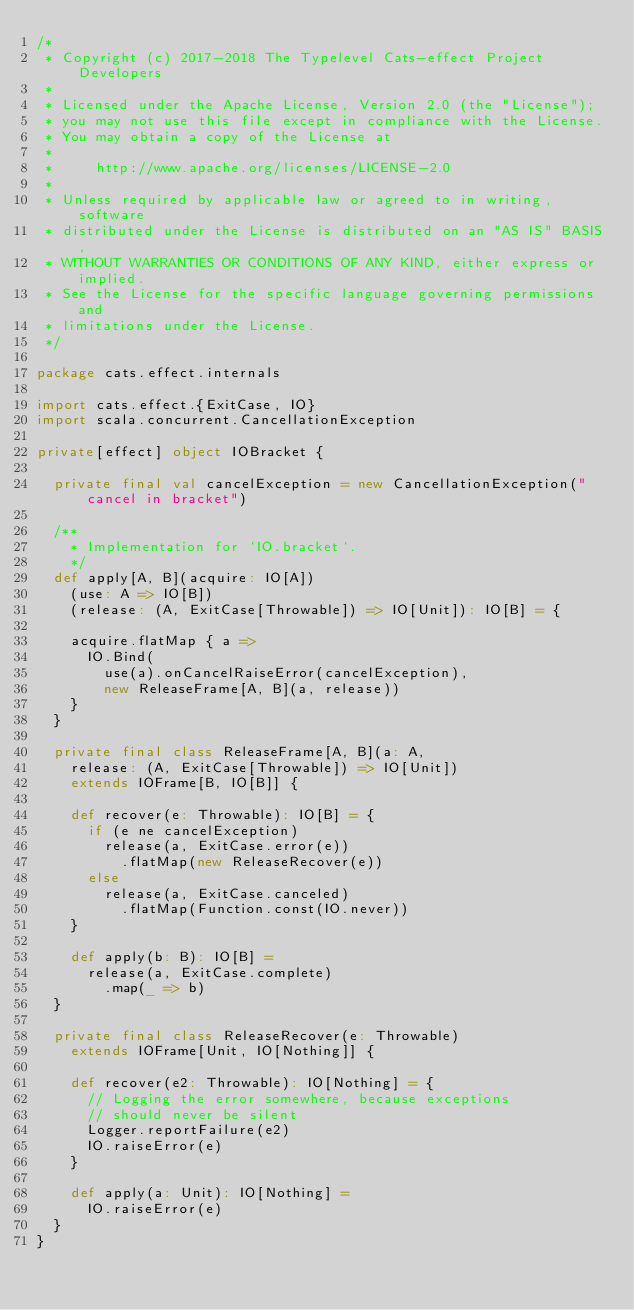<code> <loc_0><loc_0><loc_500><loc_500><_Scala_>/*
 * Copyright (c) 2017-2018 The Typelevel Cats-effect Project Developers
 *
 * Licensed under the Apache License, Version 2.0 (the "License");
 * you may not use this file except in compliance with the License.
 * You may obtain a copy of the License at
 *
 *     http://www.apache.org/licenses/LICENSE-2.0
 *
 * Unless required by applicable law or agreed to in writing, software
 * distributed under the License is distributed on an "AS IS" BASIS,
 * WITHOUT WARRANTIES OR CONDITIONS OF ANY KIND, either express or implied.
 * See the License for the specific language governing permissions and
 * limitations under the License.
 */

package cats.effect.internals

import cats.effect.{ExitCase, IO}
import scala.concurrent.CancellationException

private[effect] object IOBracket {

  private final val cancelException = new CancellationException("cancel in bracket")

  /**
    * Implementation for `IO.bracket`.
    */
  def apply[A, B](acquire: IO[A])
    (use: A => IO[B])
    (release: (A, ExitCase[Throwable]) => IO[Unit]): IO[B] = {

    acquire.flatMap { a =>
      IO.Bind(
        use(a).onCancelRaiseError(cancelException),
        new ReleaseFrame[A, B](a, release))
    }
  }

  private final class ReleaseFrame[A, B](a: A,
    release: (A, ExitCase[Throwable]) => IO[Unit])
    extends IOFrame[B, IO[B]] {

    def recover(e: Throwable): IO[B] = {
      if (e ne cancelException)
        release(a, ExitCase.error(e))
          .flatMap(new ReleaseRecover(e))
      else
        release(a, ExitCase.canceled)
          .flatMap(Function.const(IO.never))
    }

    def apply(b: B): IO[B] =
      release(a, ExitCase.complete)
        .map(_ => b)
  }

  private final class ReleaseRecover(e: Throwable)
    extends IOFrame[Unit, IO[Nothing]] {

    def recover(e2: Throwable): IO[Nothing] = {
      // Logging the error somewhere, because exceptions
      // should never be silent
      Logger.reportFailure(e2)
      IO.raiseError(e)
    }

    def apply(a: Unit): IO[Nothing] =
      IO.raiseError(e)
  }
}
</code> 